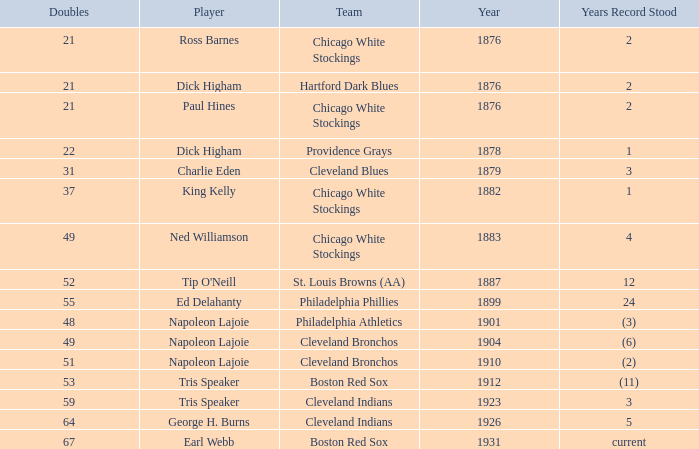Player of napoleon lajoie, and a Team of cleveland bronchos, and a Doubles of 49 which years record stood? (6). 